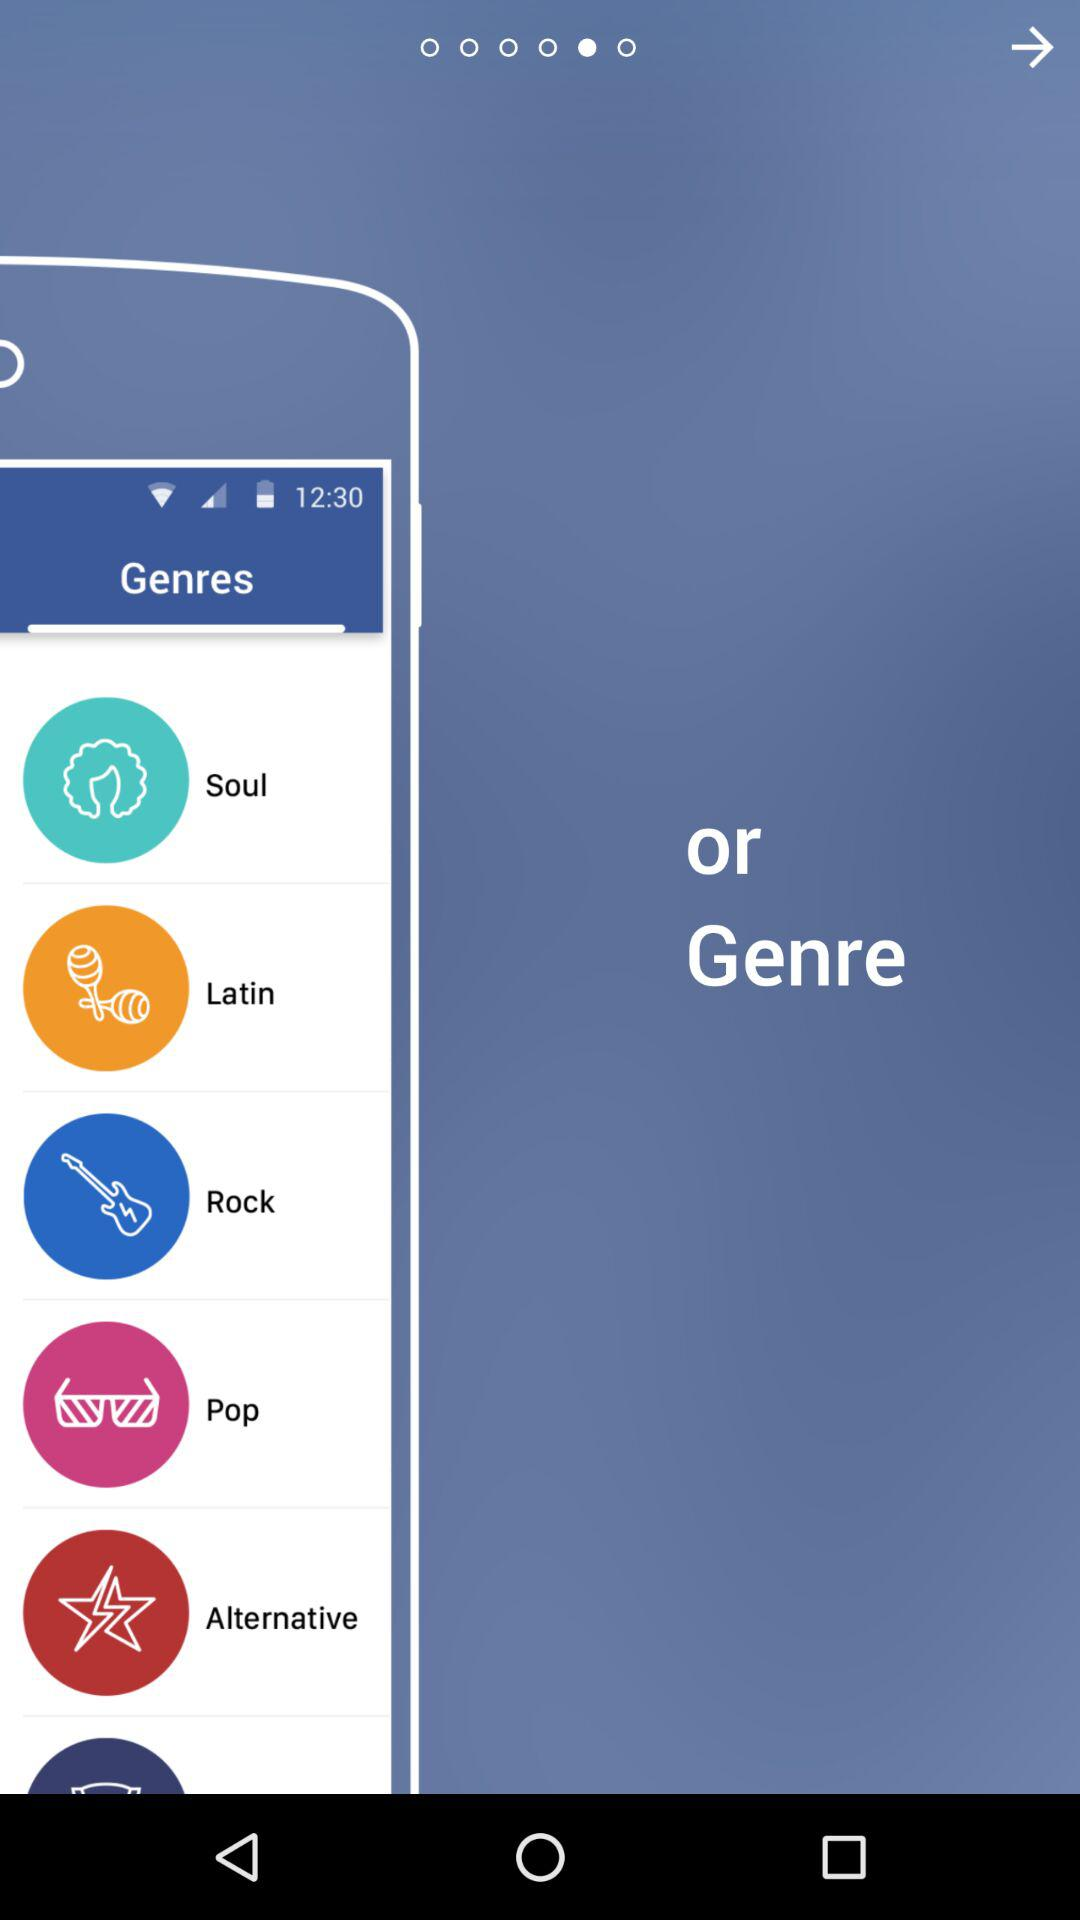How many genres are there after the first one?
Answer the question using a single word or phrase. 5 